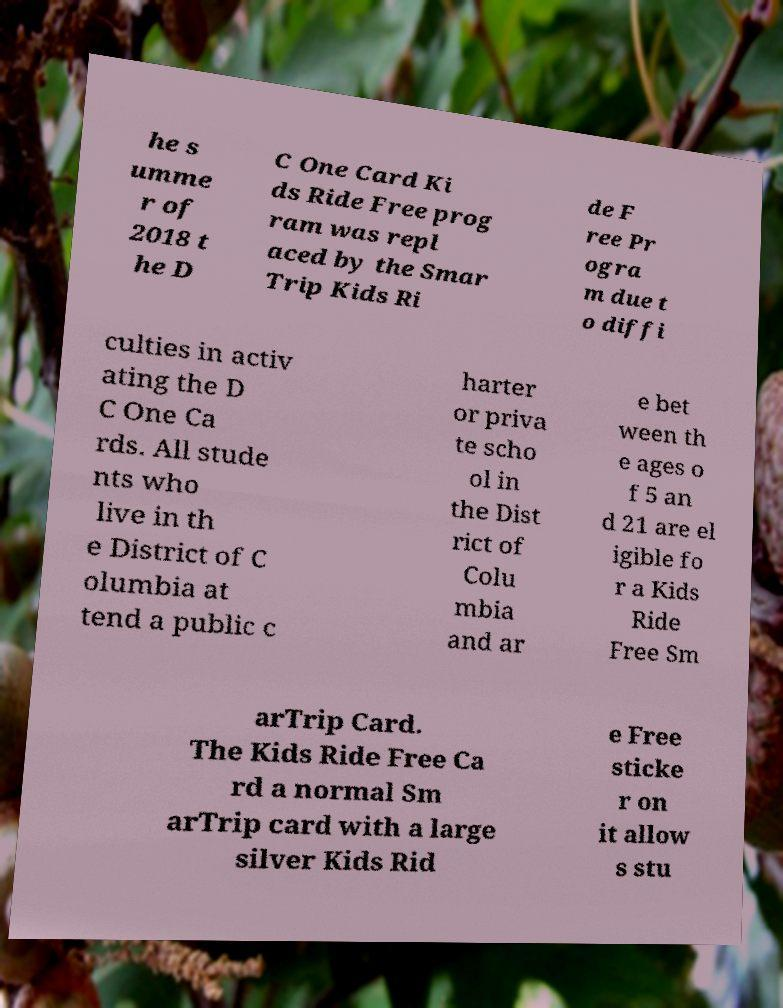Please read and relay the text visible in this image. What does it say? he s umme r of 2018 t he D C One Card Ki ds Ride Free prog ram was repl aced by the Smar Trip Kids Ri de F ree Pr ogra m due t o diffi culties in activ ating the D C One Ca rds. All stude nts who live in th e District of C olumbia at tend a public c harter or priva te scho ol in the Dist rict of Colu mbia and ar e bet ween th e ages o f 5 an d 21 are el igible fo r a Kids Ride Free Sm arTrip Card. The Kids Ride Free Ca rd a normal Sm arTrip card with a large silver Kids Rid e Free sticke r on it allow s stu 